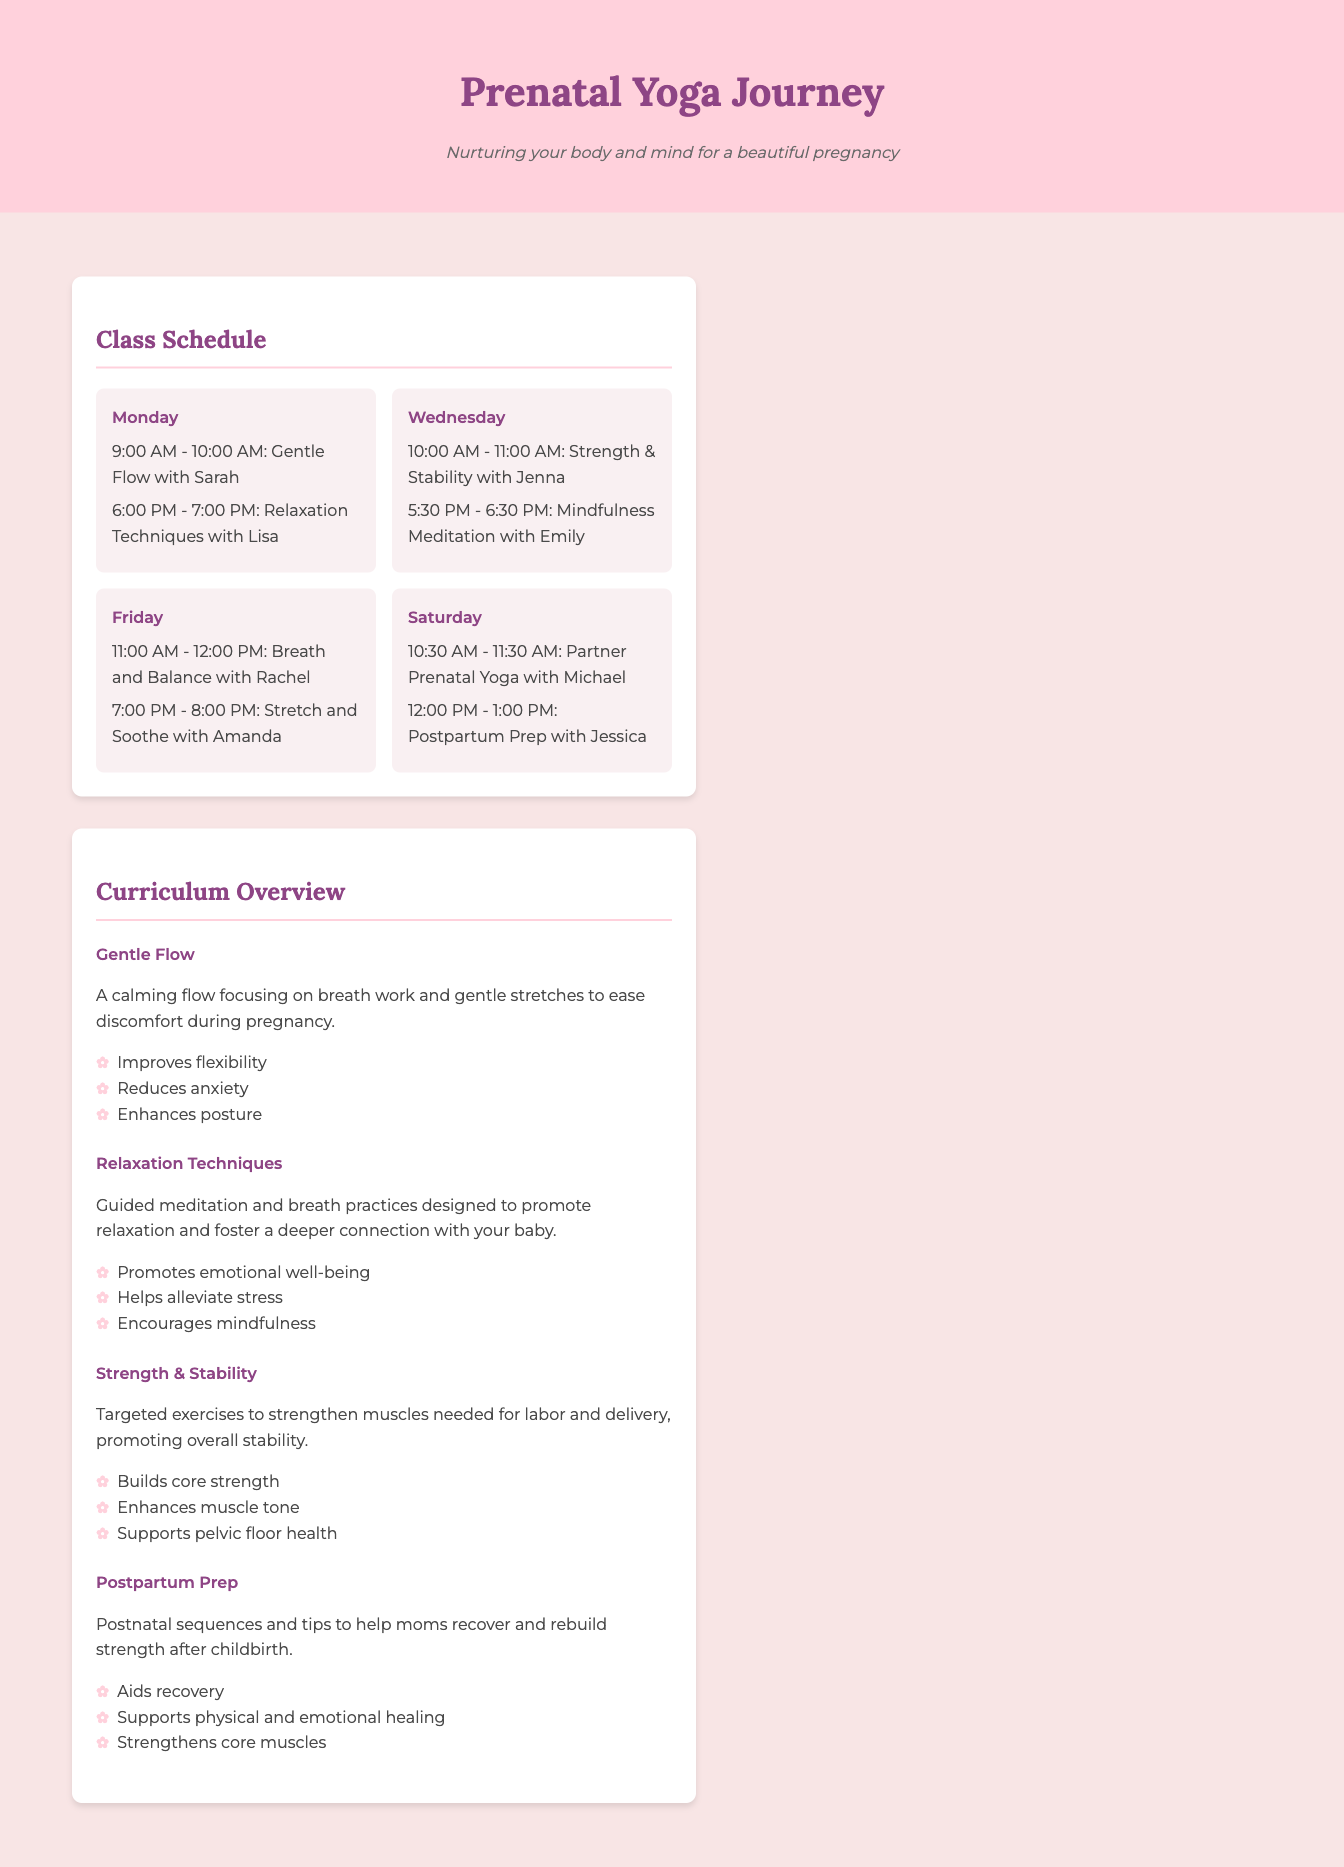What is the time for the Gentle Flow class on Monday? The document specifies that the Gentle Flow class on Monday is from 9:00 AM to 10:00 AM.
Answer: 9:00 AM - 10:00 AM Who teaches the Relaxation Techniques class? According to the schedule, the Relaxation Techniques class is taught by Lisa.
Answer: Lisa How many classes are held on Saturday? The document lists two classes scheduled on Saturday, one for Partner Prenatal Yoga and one for Postpartum Prep.
Answer: 2 What benefit does the Gentle Flow curriculum provide? The provided benefit is that it improves flexibility among other benefits mentioned in the curriculum overview.
Answer: Improves flexibility What is the main goal of the Postpartum Prep class? The document describes the main goal of the Postpartum Prep class as helping moms recover and rebuild strength after childbirth.
Answer: Help moms recover What day of the week features the Strength & Stability class? The schedule indicates that the Strength & Stability class is held on Wednesday.
Answer: Wednesday What type of exercises does the Strength & Stability class focus on? It focuses on targeted exercises to strengthen muscles needed for labor and delivery.
Answer: Targeted exercises Which class specifically promotes emotional well-being? The Relaxation Techniques class is designed to promote emotional well-being as stated in the curriculum overview.
Answer: Relaxation Techniques 